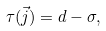<formula> <loc_0><loc_0><loc_500><loc_500>\tau ( { \vec { j } } ) = d - \sigma ,</formula> 